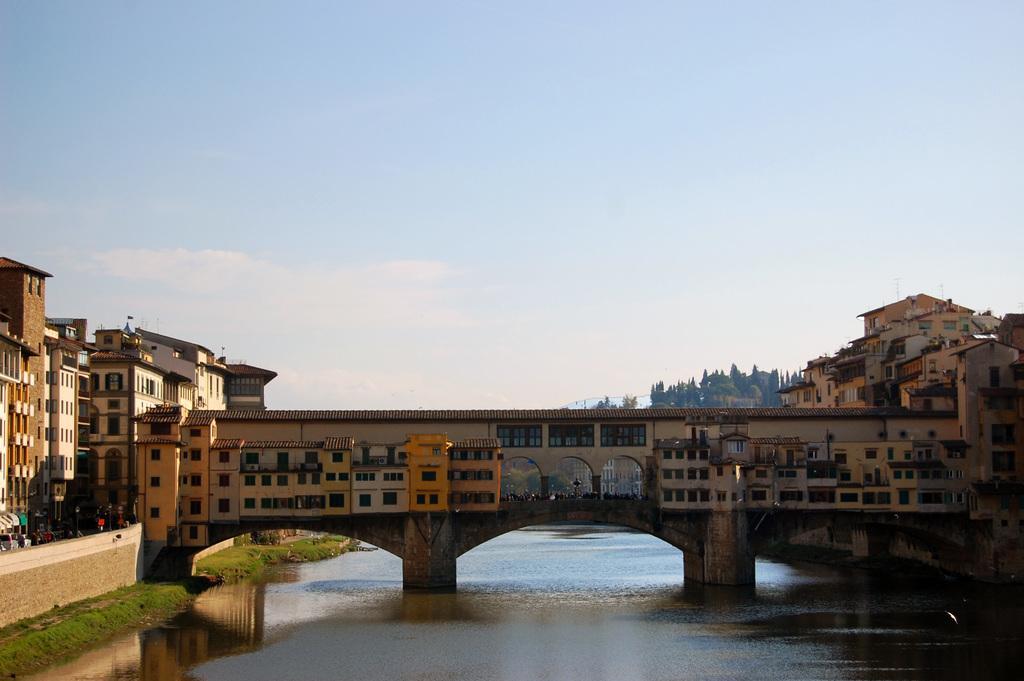Could you give a brief overview of what you see in this image? In this image in the center there is a bridge and in the background there are some buildings, trees. At the bottom there is a lake and also we can see some grass, wall and some objects. At the top there is sky. 